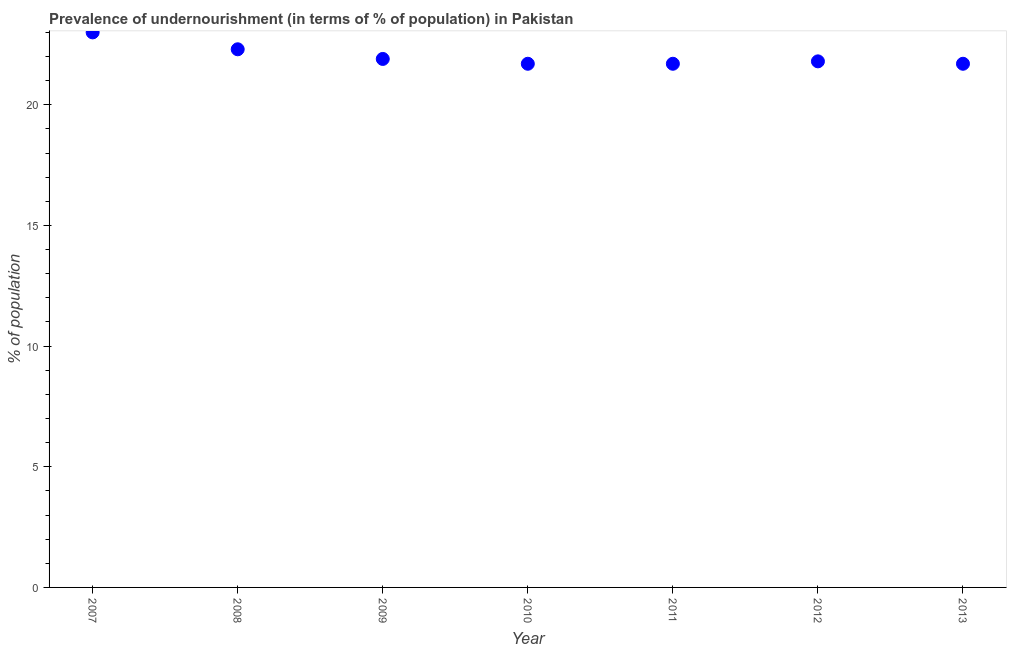What is the percentage of undernourished population in 2012?
Offer a terse response. 21.8. Across all years, what is the minimum percentage of undernourished population?
Give a very brief answer. 21.7. What is the sum of the percentage of undernourished population?
Keep it short and to the point. 154.1. What is the difference between the percentage of undernourished population in 2007 and 2012?
Keep it short and to the point. 1.2. What is the average percentage of undernourished population per year?
Your response must be concise. 22.01. What is the median percentage of undernourished population?
Keep it short and to the point. 21.8. Do a majority of the years between 2013 and 2007 (inclusive) have percentage of undernourished population greater than 17 %?
Offer a very short reply. Yes. What is the ratio of the percentage of undernourished population in 2009 to that in 2010?
Provide a succinct answer. 1.01. Is the percentage of undernourished population in 2008 less than that in 2011?
Offer a terse response. No. Is the difference between the percentage of undernourished population in 2007 and 2008 greater than the difference between any two years?
Your response must be concise. No. What is the difference between the highest and the second highest percentage of undernourished population?
Your answer should be compact. 0.7. Is the sum of the percentage of undernourished population in 2009 and 2011 greater than the maximum percentage of undernourished population across all years?
Provide a short and direct response. Yes. What is the difference between the highest and the lowest percentage of undernourished population?
Keep it short and to the point. 1.3. How many dotlines are there?
Give a very brief answer. 1. What is the difference between two consecutive major ticks on the Y-axis?
Your answer should be very brief. 5. Are the values on the major ticks of Y-axis written in scientific E-notation?
Give a very brief answer. No. Does the graph contain any zero values?
Your response must be concise. No. Does the graph contain grids?
Offer a very short reply. No. What is the title of the graph?
Provide a short and direct response. Prevalence of undernourishment (in terms of % of population) in Pakistan. What is the label or title of the X-axis?
Ensure brevity in your answer.  Year. What is the label or title of the Y-axis?
Ensure brevity in your answer.  % of population. What is the % of population in 2008?
Your answer should be compact. 22.3. What is the % of population in 2009?
Your answer should be very brief. 21.9. What is the % of population in 2010?
Your response must be concise. 21.7. What is the % of population in 2011?
Provide a short and direct response. 21.7. What is the % of population in 2012?
Keep it short and to the point. 21.8. What is the % of population in 2013?
Give a very brief answer. 21.7. What is the difference between the % of population in 2007 and 2008?
Provide a short and direct response. 0.7. What is the difference between the % of population in 2007 and 2010?
Provide a short and direct response. 1.3. What is the difference between the % of population in 2007 and 2011?
Keep it short and to the point. 1.3. What is the difference between the % of population in 2007 and 2012?
Give a very brief answer. 1.2. What is the difference between the % of population in 2007 and 2013?
Provide a short and direct response. 1.3. What is the difference between the % of population in 2008 and 2010?
Provide a short and direct response. 0.6. What is the difference between the % of population in 2009 and 2010?
Your answer should be very brief. 0.2. What is the difference between the % of population in 2009 and 2011?
Your answer should be compact. 0.2. What is the difference between the % of population in 2009 and 2013?
Your answer should be compact. 0.2. What is the difference between the % of population in 2010 and 2011?
Your response must be concise. 0. What is the difference between the % of population in 2010 and 2013?
Your answer should be compact. 0. What is the ratio of the % of population in 2007 to that in 2008?
Keep it short and to the point. 1.03. What is the ratio of the % of population in 2007 to that in 2009?
Keep it short and to the point. 1.05. What is the ratio of the % of population in 2007 to that in 2010?
Make the answer very short. 1.06. What is the ratio of the % of population in 2007 to that in 2011?
Ensure brevity in your answer.  1.06. What is the ratio of the % of population in 2007 to that in 2012?
Keep it short and to the point. 1.05. What is the ratio of the % of population in 2007 to that in 2013?
Give a very brief answer. 1.06. What is the ratio of the % of population in 2008 to that in 2009?
Keep it short and to the point. 1.02. What is the ratio of the % of population in 2008 to that in 2010?
Make the answer very short. 1.03. What is the ratio of the % of population in 2008 to that in 2011?
Your answer should be very brief. 1.03. What is the ratio of the % of population in 2008 to that in 2013?
Your response must be concise. 1.03. What is the ratio of the % of population in 2009 to that in 2010?
Your answer should be very brief. 1.01. What is the ratio of the % of population in 2009 to that in 2011?
Your answer should be very brief. 1.01. What is the ratio of the % of population in 2009 to that in 2013?
Give a very brief answer. 1.01. What is the ratio of the % of population in 2010 to that in 2011?
Give a very brief answer. 1. What is the ratio of the % of population in 2010 to that in 2012?
Give a very brief answer. 0.99. What is the ratio of the % of population in 2011 to that in 2013?
Offer a very short reply. 1. What is the ratio of the % of population in 2012 to that in 2013?
Offer a terse response. 1. 